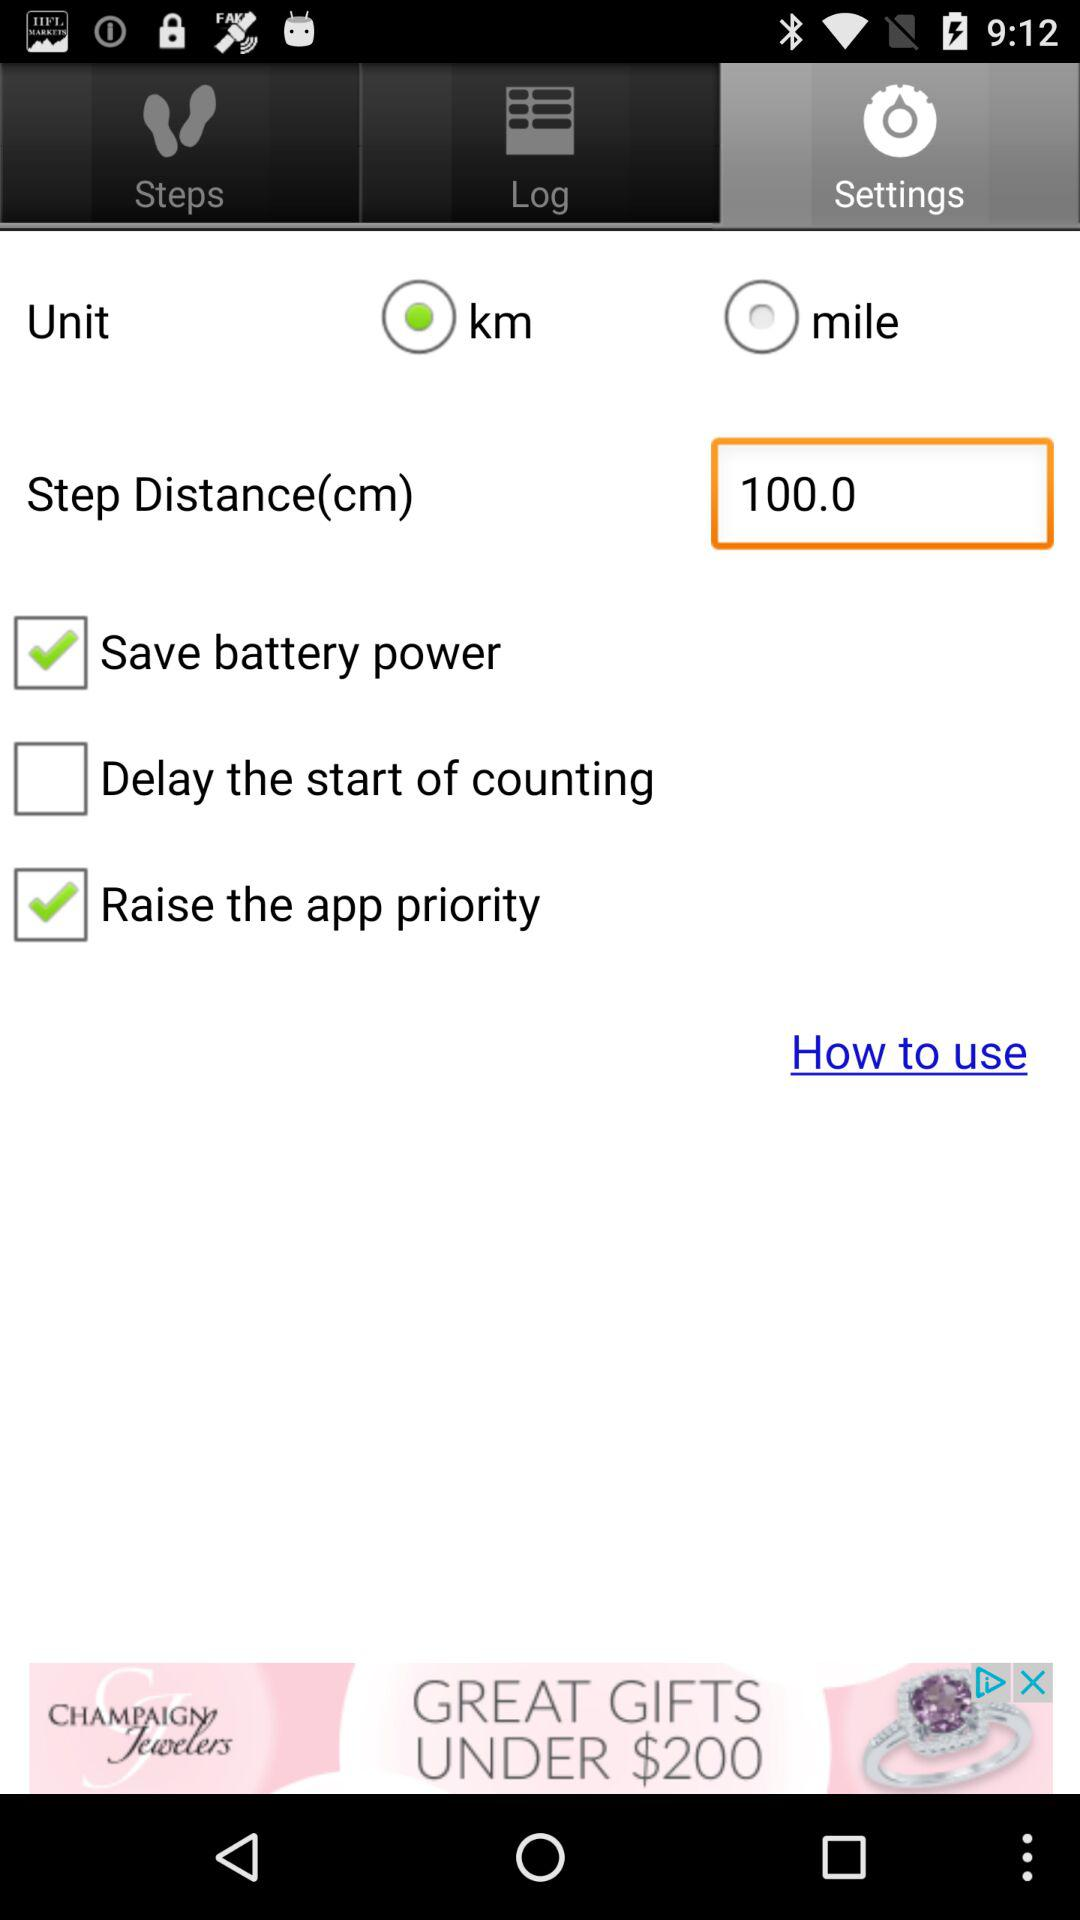Which tab has been selected? The tab that has been selected is "Settings". 